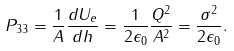Convert formula to latex. <formula><loc_0><loc_0><loc_500><loc_500>P _ { 3 3 } = \frac { 1 } { A } \frac { d U _ { e } } { d h } = \frac { 1 } { 2 \epsilon _ { 0 } } \frac { Q ^ { 2 } } { A ^ { 2 } } = \frac { \sigma ^ { 2 } } { 2 \epsilon _ { 0 } } .</formula> 